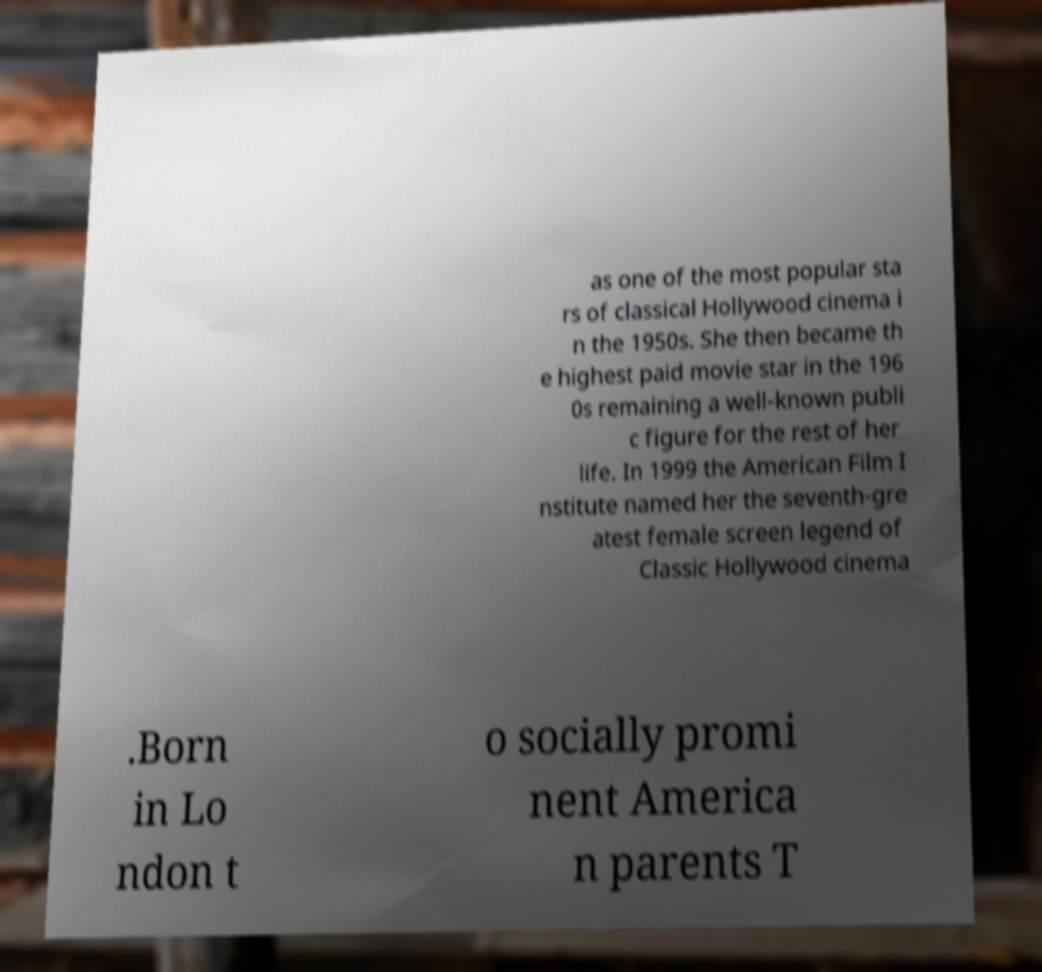Could you assist in decoding the text presented in this image and type it out clearly? as one of the most popular sta rs of classical Hollywood cinema i n the 1950s. She then became th e highest paid movie star in the 196 0s remaining a well-known publi c figure for the rest of her life. In 1999 the American Film I nstitute named her the seventh-gre atest female screen legend of Classic Hollywood cinema .Born in Lo ndon t o socially promi nent America n parents T 